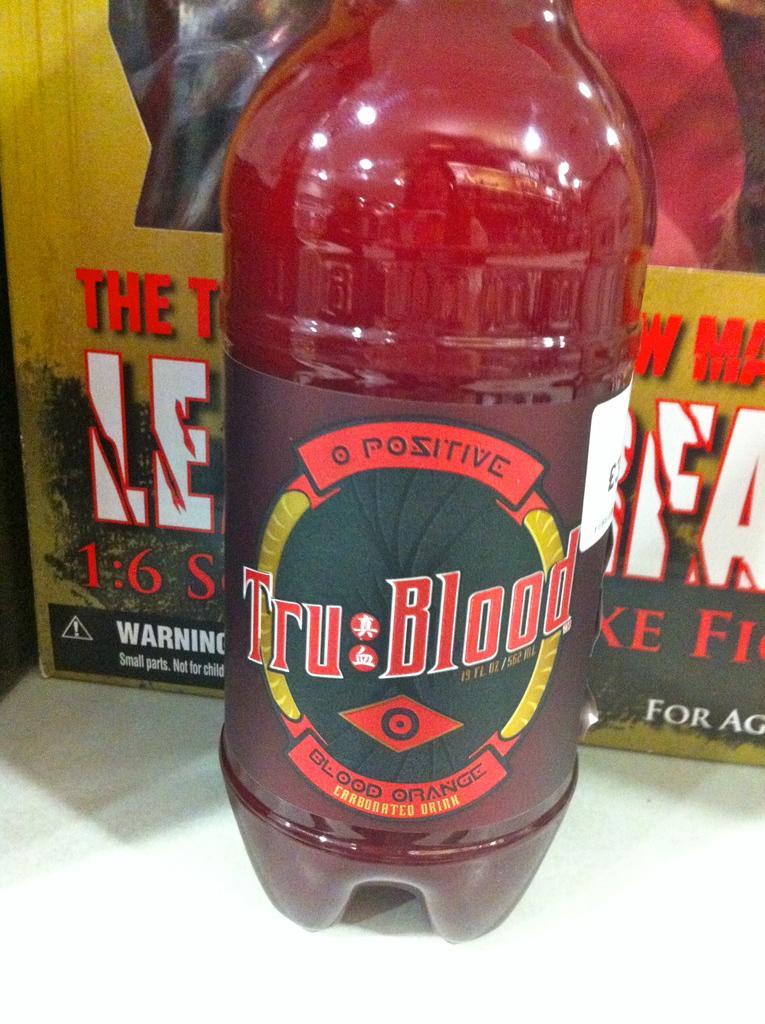Could you give a brief overview of what you see in this image? In this image we can see a bottle with label and drink in it. In the background we can see a box. 